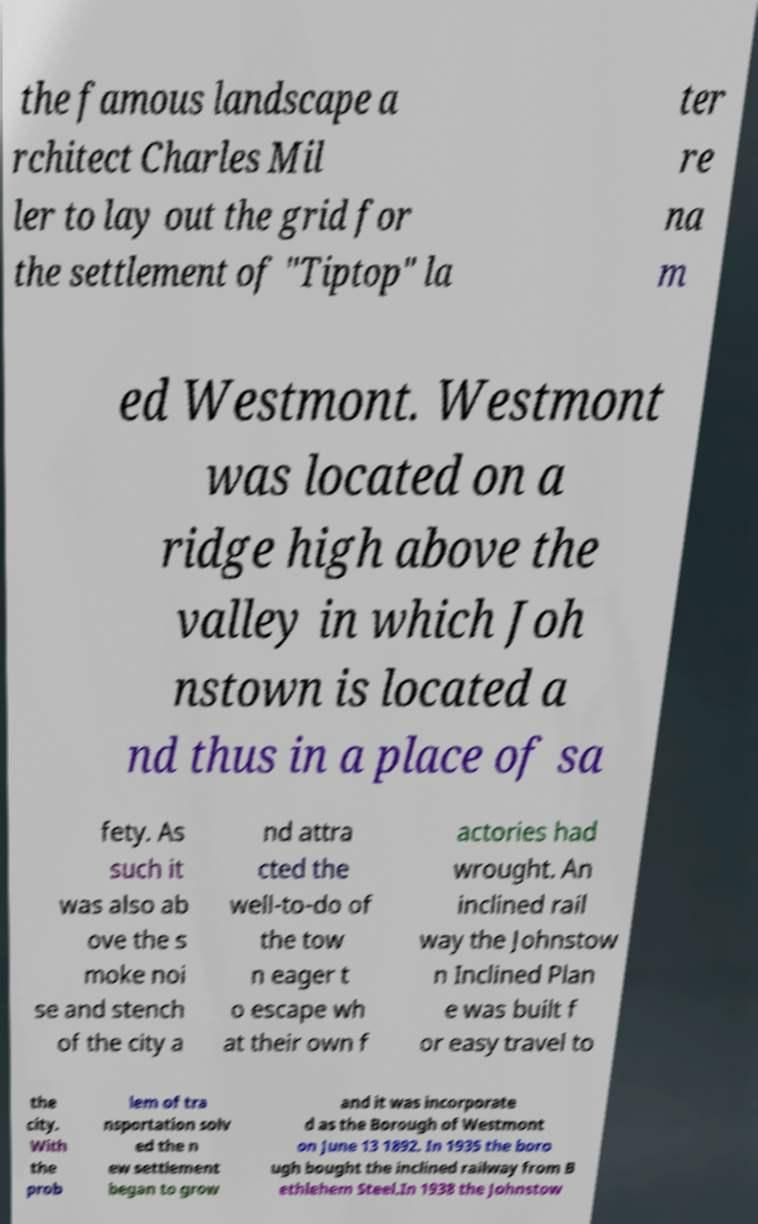There's text embedded in this image that I need extracted. Can you transcribe it verbatim? the famous landscape a rchitect Charles Mil ler to lay out the grid for the settlement of "Tiptop" la ter re na m ed Westmont. Westmont was located on a ridge high above the valley in which Joh nstown is located a nd thus in a place of sa fety. As such it was also ab ove the s moke noi se and stench of the city a nd attra cted the well-to-do of the tow n eager t o escape wh at their own f actories had wrought. An inclined rail way the Johnstow n Inclined Plan e was built f or easy travel to the city. With the prob lem of tra nsportation solv ed the n ew settlement began to grow and it was incorporate d as the Borough of Westmont on June 13 1892. In 1935 the boro ugh bought the inclined railway from B ethlehem Steel.In 1938 the Johnstow 